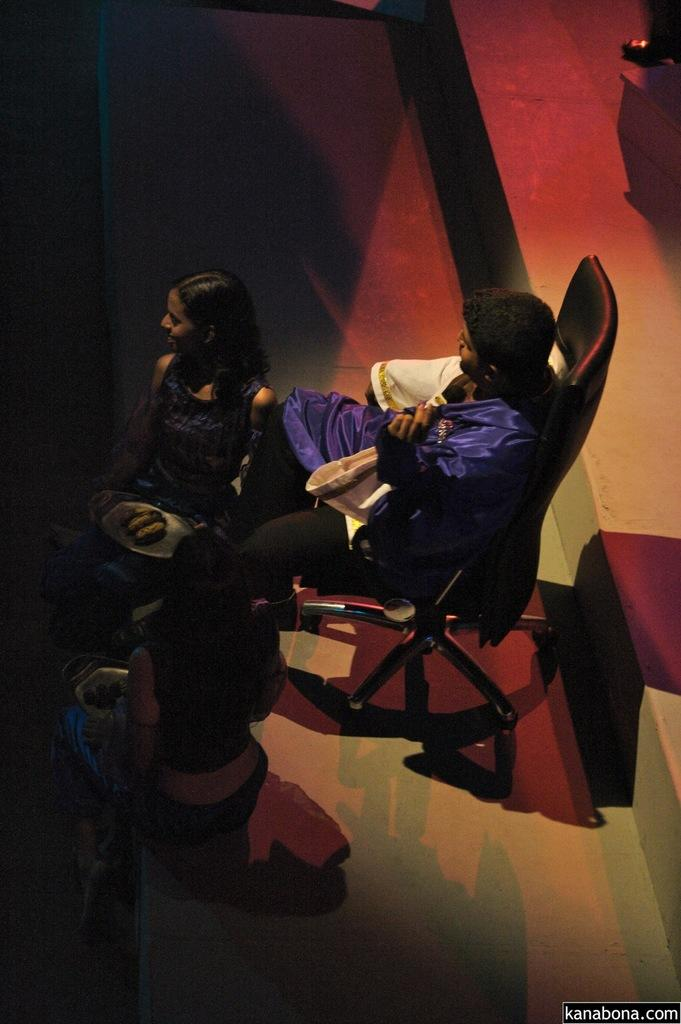What is the man in the image doing? The man is sitting on a chair in the image. Who is sitting next to the man? There are two women sitting on either side of the man's legs. What are the women holding in their hands? Each woman is holding a plate in her hand. What type of sound can be heard coming from the cherry in the image? There is no cherry present in the image, so it is not possible to determine what, if any, sound might be heard. 